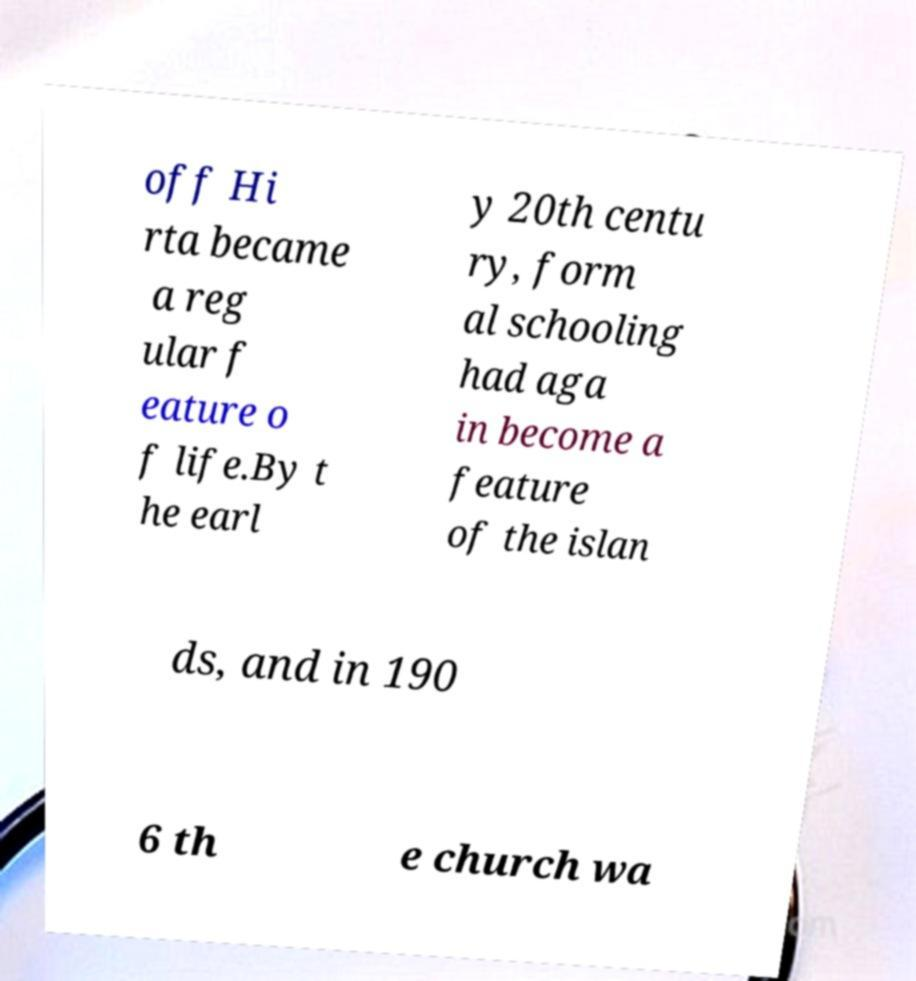There's text embedded in this image that I need extracted. Can you transcribe it verbatim? off Hi rta became a reg ular f eature o f life.By t he earl y 20th centu ry, form al schooling had aga in become a feature of the islan ds, and in 190 6 th e church wa 